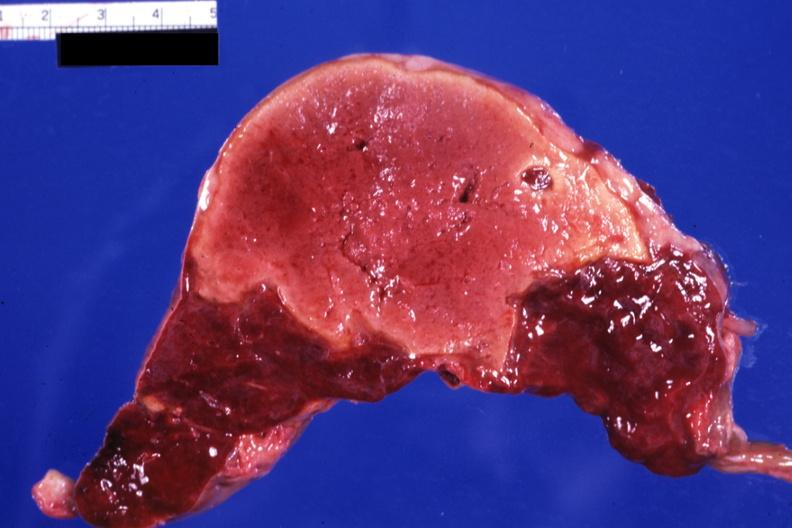s hematologic present?
Answer the question using a single word or phrase. Yes 